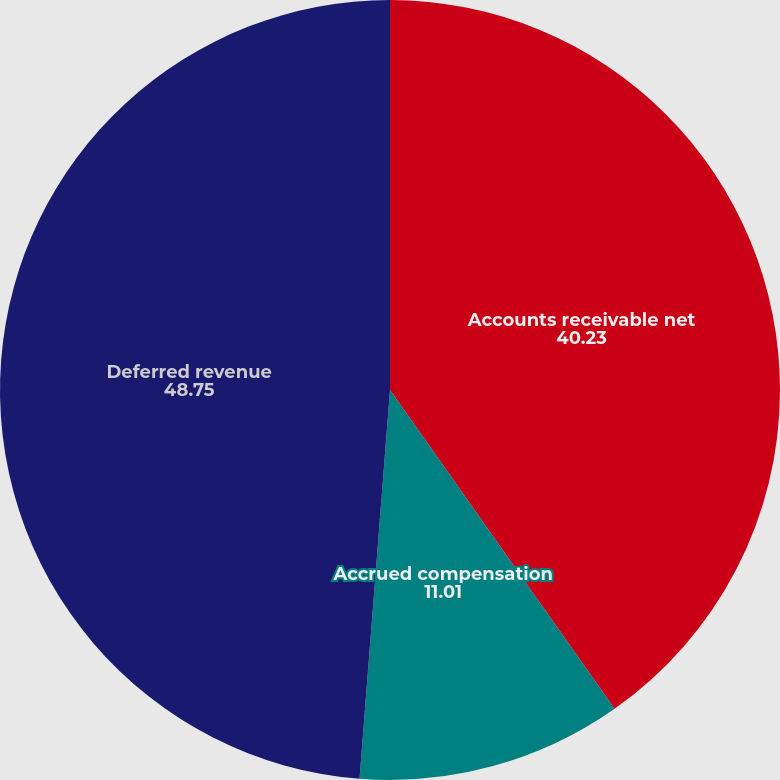<chart> <loc_0><loc_0><loc_500><loc_500><pie_chart><fcel>Accounts receivable net<fcel>Accrued compensation<fcel>Deferred revenue<nl><fcel>40.23%<fcel>11.01%<fcel>48.75%<nl></chart> 